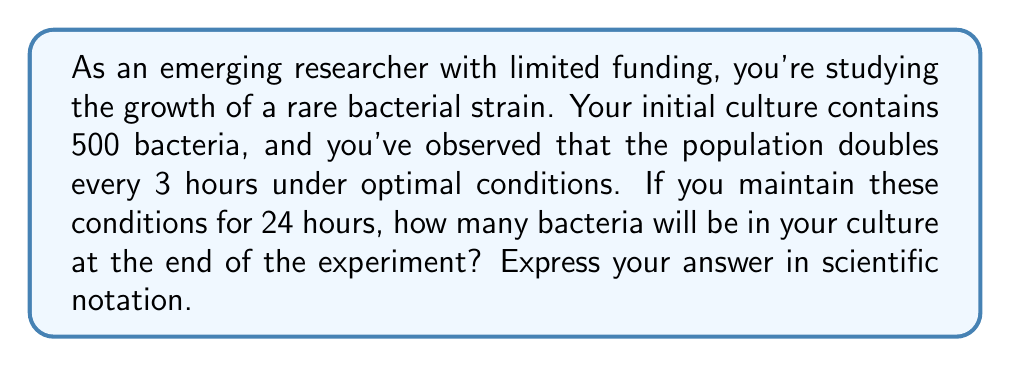Can you answer this question? Let's approach this step-by-step:

1. Identify the key information:
   - Initial population: $N_0 = 500$ bacteria
   - Doubling time: 3 hours
   - Total experiment time: 24 hours

2. Calculate the number of doubling periods in 24 hours:
   $\text{Number of doublings} = \frac{24 \text{ hours}}{3 \text{ hours/doubling}} = 8 \text{ doublings}$

3. Use the exponential growth formula:
   $N = N_0 \cdot 2^n$
   Where:
   $N$ is the final population
   $N_0$ is the initial population
   $n$ is the number of doubling periods

4. Plug in the values:
   $N = 500 \cdot 2^8$

5. Calculate:
   $N = 500 \cdot 256 = 128,000$

6. Convert to scientific notation:
   $N = 1.28 \times 10^5$
Answer: $1.28 \times 10^5$ bacteria 